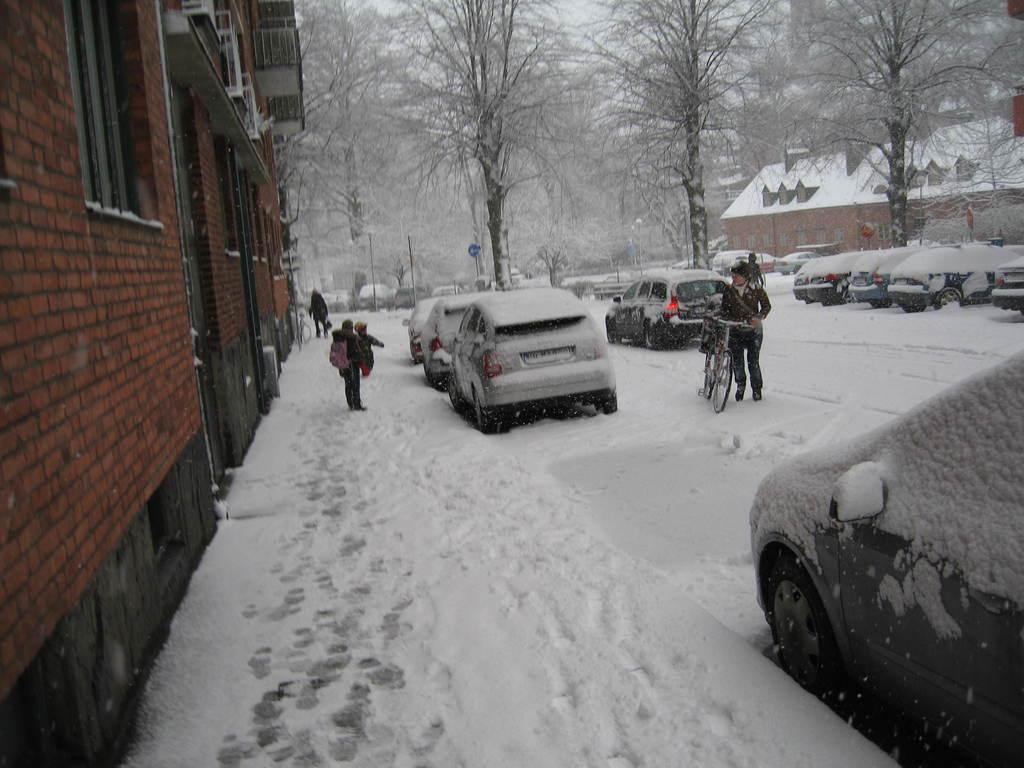How would you summarize this image in a sentence or two? This is a picture taken on the streets of a city. In the center of the picture there are cars, people, trees and a bicycle. On the left there are buildings. In the background there are houses and trees. 